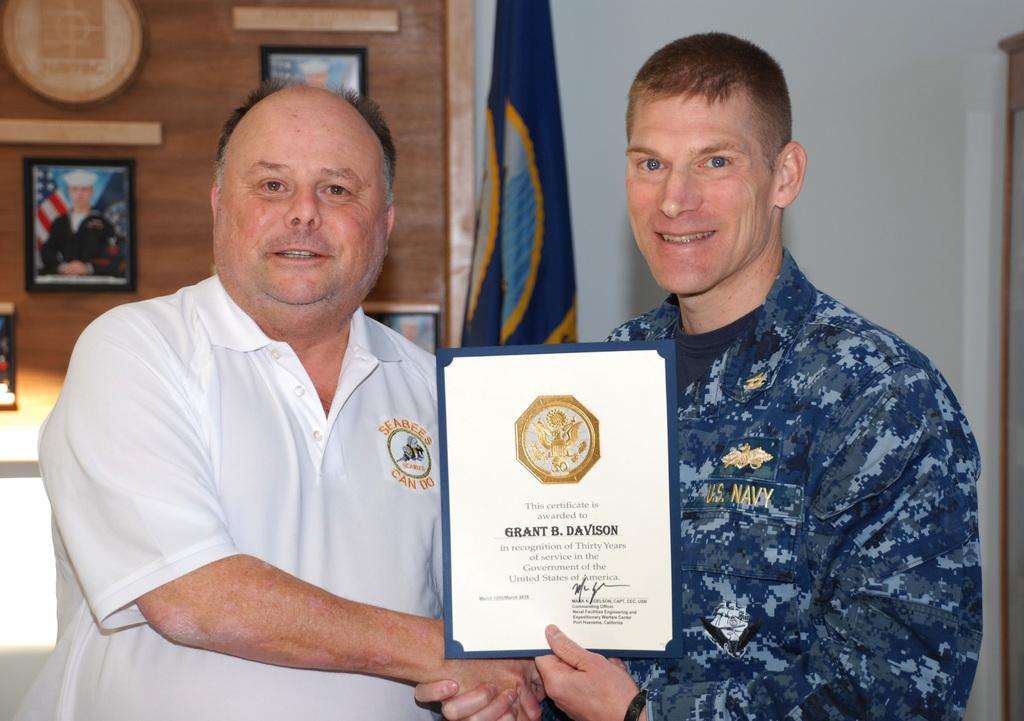How many people are in the image? There are two men in the image. What are the men holding in the image? The men are holding a certificate. What can be seen in the background of the image? There are frames and a flag in the background of the image. What type of structure is visible in the background? There is a wall in the background of the image. What type of grass is visible in the image? There is no grass visible in the image. What details can be seen on the frames in the background? The provided facts do not mention any specific details about the frames in the background. 